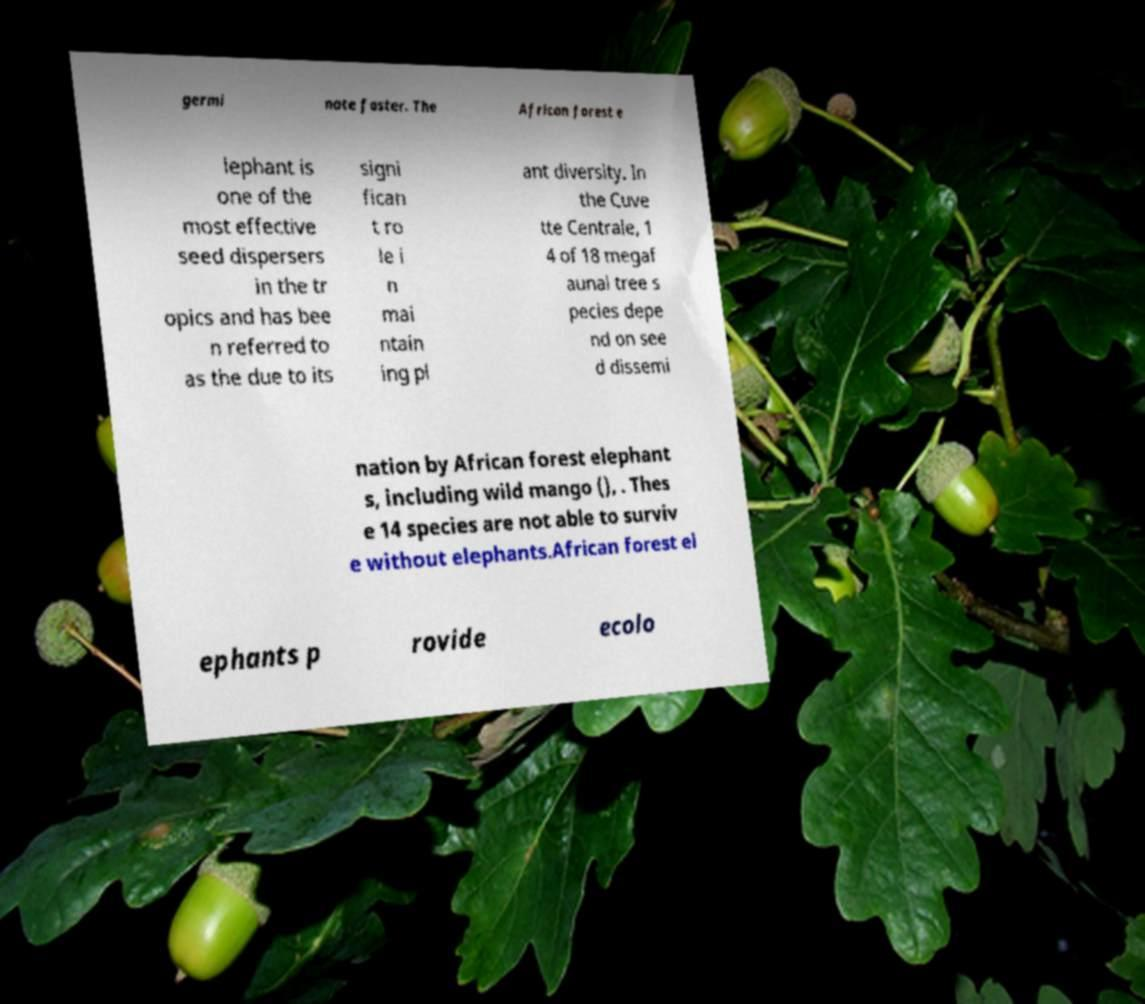Can you read and provide the text displayed in the image?This photo seems to have some interesting text. Can you extract and type it out for me? germi nate faster. The African forest e lephant is one of the most effective seed dispersers in the tr opics and has bee n referred to as the due to its signi fican t ro le i n mai ntain ing pl ant diversity. In the Cuve tte Centrale, 1 4 of 18 megaf aunal tree s pecies depe nd on see d dissemi nation by African forest elephant s, including wild mango (), . Thes e 14 species are not able to surviv e without elephants.African forest el ephants p rovide ecolo 